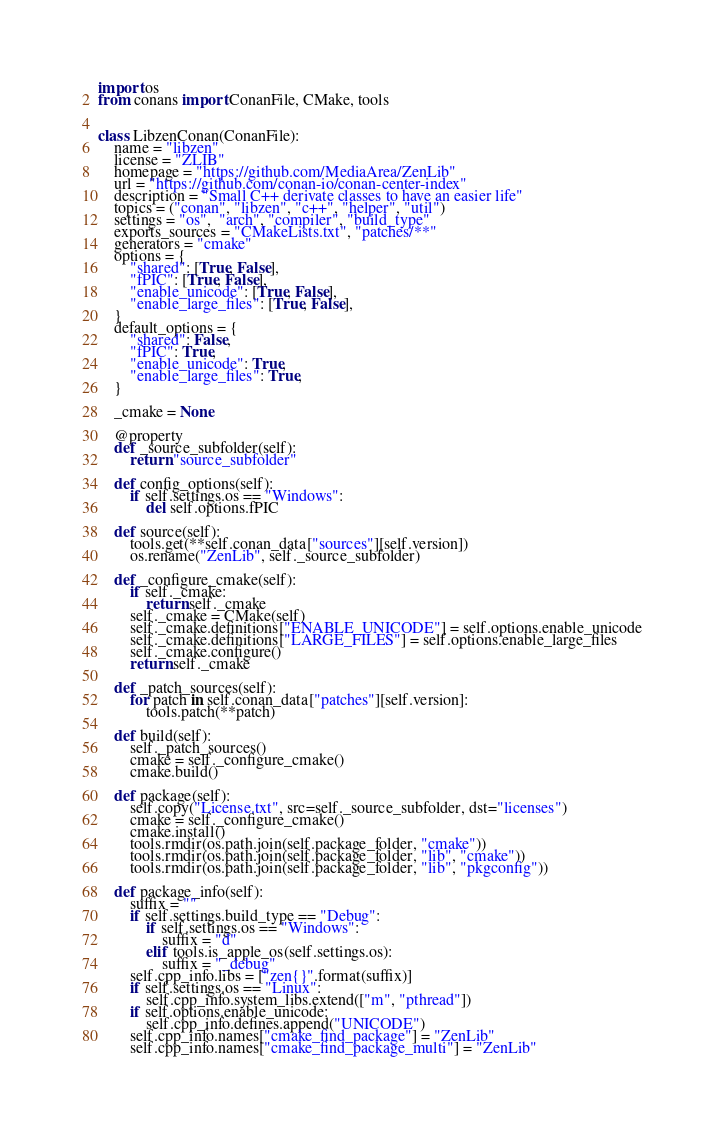<code> <loc_0><loc_0><loc_500><loc_500><_Python_>import os
from conans import ConanFile, CMake, tools


class LibzenConan(ConanFile):
    name = "libzen"
    license = "ZLIB"
    homepage = "https://github.com/MediaArea/ZenLib"
    url = "https://github.com/conan-io/conan-center-index"
    description = "Small C++ derivate classes to have an easier life"
    topics = ("conan", "libzen", "c++", "helper", "util")
    settings = "os",  "arch", "compiler", "build_type"
    exports_sources = "CMakeLists.txt", "patches/**"
    generators = "cmake"
    options = {
        "shared": [True, False],
        "fPIC": [True, False],
        "enable_unicode": [True, False],
        "enable_large_files": [True, False],
    }
    default_options = {
        "shared": False,
        "fPIC": True,
        "enable_unicode": True,
        "enable_large_files": True,
    }

    _cmake = None

    @property
    def _source_subfolder(self):
        return "source_subfolder"

    def config_options(self):
        if self.settings.os == "Windows":
            del self.options.fPIC

    def source(self):
        tools.get(**self.conan_data["sources"][self.version])
        os.rename("ZenLib", self._source_subfolder)

    def _configure_cmake(self):
        if self._cmake:
            return self._cmake
        self._cmake = CMake(self)
        self._cmake.definitions["ENABLE_UNICODE"] = self.options.enable_unicode
        self._cmake.definitions["LARGE_FILES"] = self.options.enable_large_files
        self._cmake.configure()
        return self._cmake

    def _patch_sources(self):
        for patch in self.conan_data["patches"][self.version]:
            tools.patch(**patch)

    def build(self):
        self._patch_sources()
        cmake = self._configure_cmake()
        cmake.build()

    def package(self):
        self.copy("License.txt", src=self._source_subfolder, dst="licenses")
        cmake = self._configure_cmake()
        cmake.install()
        tools.rmdir(os.path.join(self.package_folder, "cmake"))
        tools.rmdir(os.path.join(self.package_folder, "lib", "cmake"))
        tools.rmdir(os.path.join(self.package_folder, "lib", "pkgconfig"))

    def package_info(self):
        suffix = ""
        if self.settings.build_type == "Debug":
            if self.settings.os == "Windows":
                suffix = "d"
            elif tools.is_apple_os(self.settings.os):
                suffix = "_debug"
        self.cpp_info.libs = ["zen{}".format(suffix)]
        if self.settings.os == "Linux":
            self.cpp_info.system_libs.extend(["m", "pthread"])
        if self.options.enable_unicode:
            self.cpp_info.defines.append("UNICODE")
        self.cpp_info.names["cmake_find_package"] = "ZenLib"
        self.cpp_info.names["cmake_find_package_multi"] = "ZenLib"
</code> 